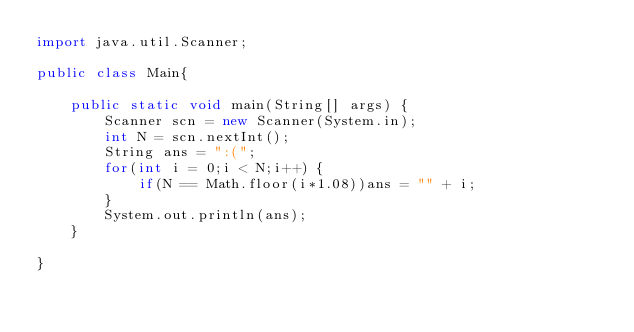<code> <loc_0><loc_0><loc_500><loc_500><_Java_>import java.util.Scanner;

public class Main{

	public static void main(String[] args) {
		Scanner scn = new Scanner(System.in);
		int N = scn.nextInt();
		String ans = ":(";
		for(int i = 0;i < N;i++) {
			if(N == Math.floor(i*1.08))ans = "" + i;
		}
		System.out.println(ans);
	}

}
</code> 